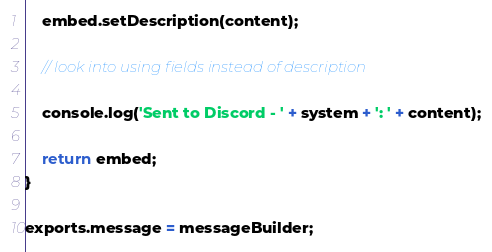<code> <loc_0><loc_0><loc_500><loc_500><_JavaScript_>	embed.setDescription(content);

    // look into using fields instead of description

	console.log('Sent to Discord - ' + system + ': ' + content);

	return embed;
}

exports.message = messageBuilder;
</code> 